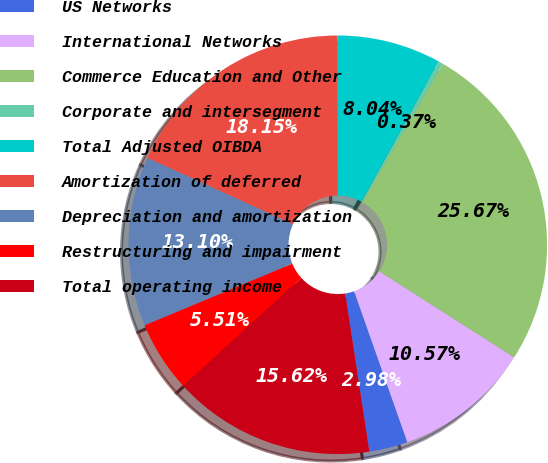Convert chart to OTSL. <chart><loc_0><loc_0><loc_500><loc_500><pie_chart><fcel>US Networks<fcel>International Networks<fcel>Commerce Education and Other<fcel>Corporate and intersegment<fcel>Total Adjusted OIBDA<fcel>Amortization of deferred<fcel>Depreciation and amortization<fcel>Restructuring and impairment<fcel>Total operating income<nl><fcel>2.98%<fcel>10.57%<fcel>25.67%<fcel>0.37%<fcel>8.04%<fcel>18.15%<fcel>13.1%<fcel>5.51%<fcel>15.62%<nl></chart> 